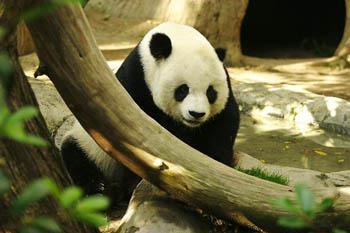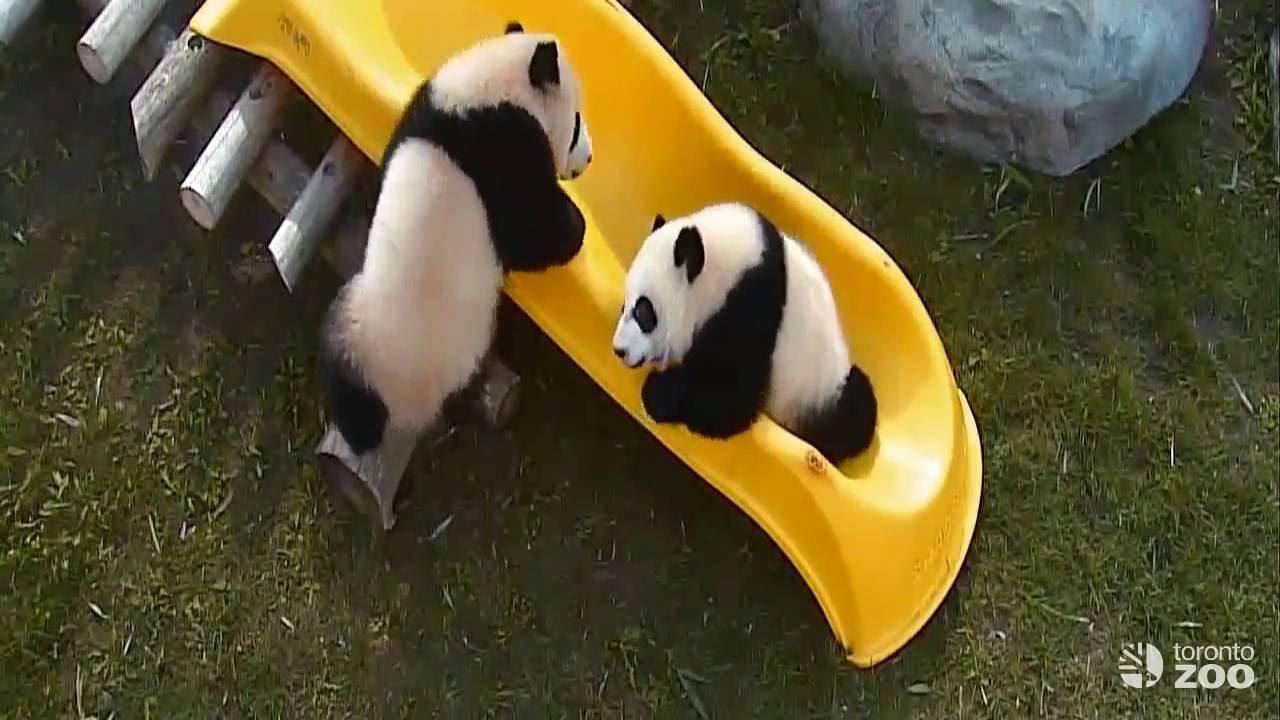The first image is the image on the left, the second image is the image on the right. Considering the images on both sides, is "One image shows at least one panda on top of bright yellow plastic playground equipment." valid? Answer yes or no. Yes. The first image is the image on the left, the second image is the image on the right. Evaluate the accuracy of this statement regarding the images: "The right image contains exactly two pandas.". Is it true? Answer yes or no. Yes. 